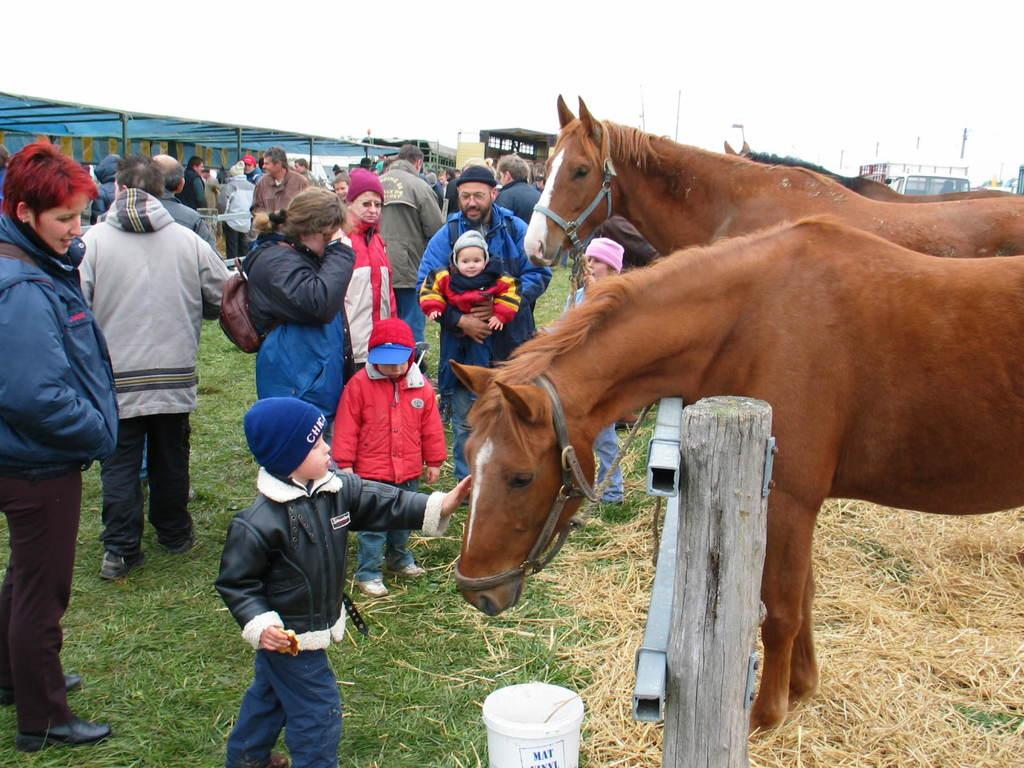How many horses are present in the image? There are 3 horses in the image. What is the setting of the image? People are standing on the grass in the image. What can be seen in the background of the image? There is a vehicle and a shed in the background of the image. What type of wing is visible on the airplane in the image? There is no airplane present in the image, so no wing can be seen. 